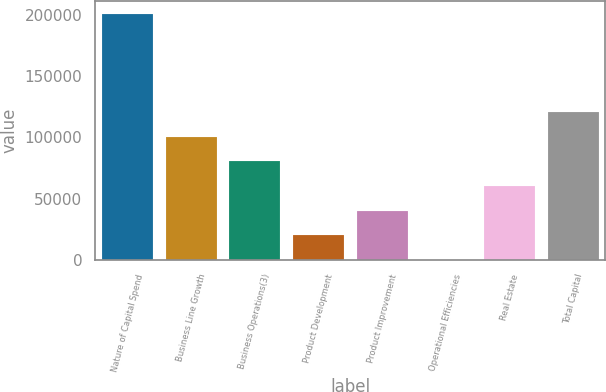Convert chart to OTSL. <chart><loc_0><loc_0><loc_500><loc_500><bar_chart><fcel>Nature of Capital Spend<fcel>Business Line Growth<fcel>Business Operations(3)<fcel>Product Development<fcel>Product Improvement<fcel>Operational Efficiencies<fcel>Real Estate<fcel>Total Capital<nl><fcel>200912<fcel>100456<fcel>80365<fcel>20091.5<fcel>40182.6<fcel>0.3<fcel>60273.8<fcel>120547<nl></chart> 